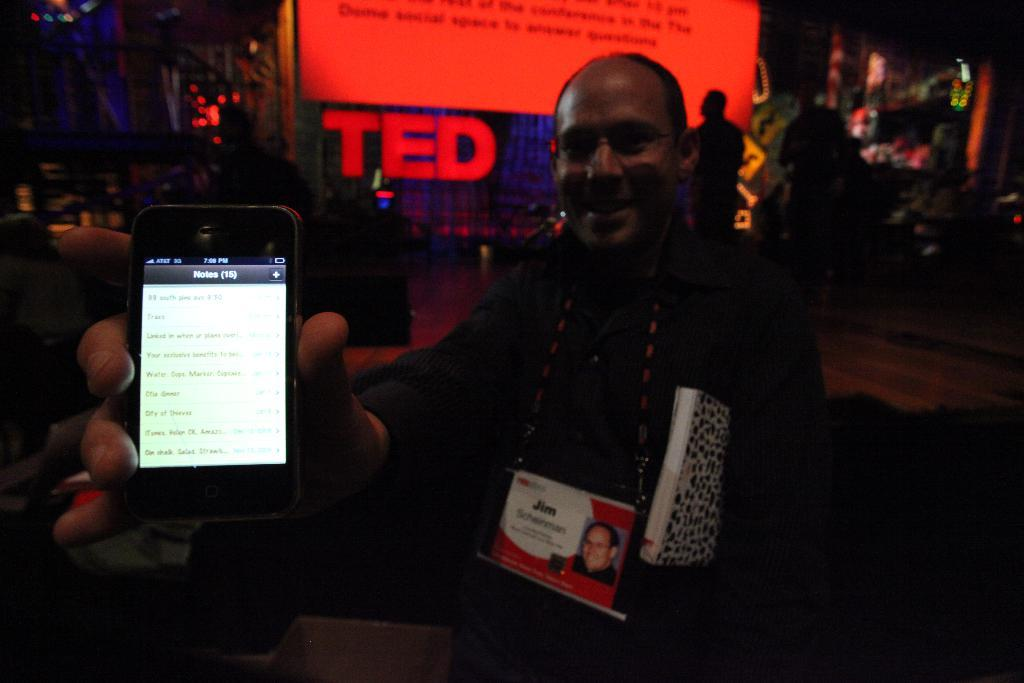What is the main subject in the center of the image? There is a person in the center of the image holding a phone. What can be seen in the background of the image? There are people in the background of the image. Is there any additional information or object visible in the image? Yes, there is a banner in the image. What type of quill is the person using to write on the banner in the image? There is no quill present in the image; the person is holding a phone, and the banner appears to be a printed or digital display. 